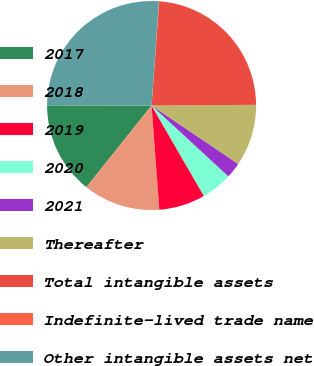Convert chart to OTSL. <chart><loc_0><loc_0><loc_500><loc_500><pie_chart><fcel>2017<fcel>2018<fcel>2019<fcel>2020<fcel>2021<fcel>Thereafter<fcel>Total intangible assets<fcel>Indefinite-lived trade name<fcel>Other intangible assets net<nl><fcel>14.29%<fcel>11.91%<fcel>7.17%<fcel>4.79%<fcel>2.42%<fcel>9.54%<fcel>23.73%<fcel>0.05%<fcel>26.1%<nl></chart> 